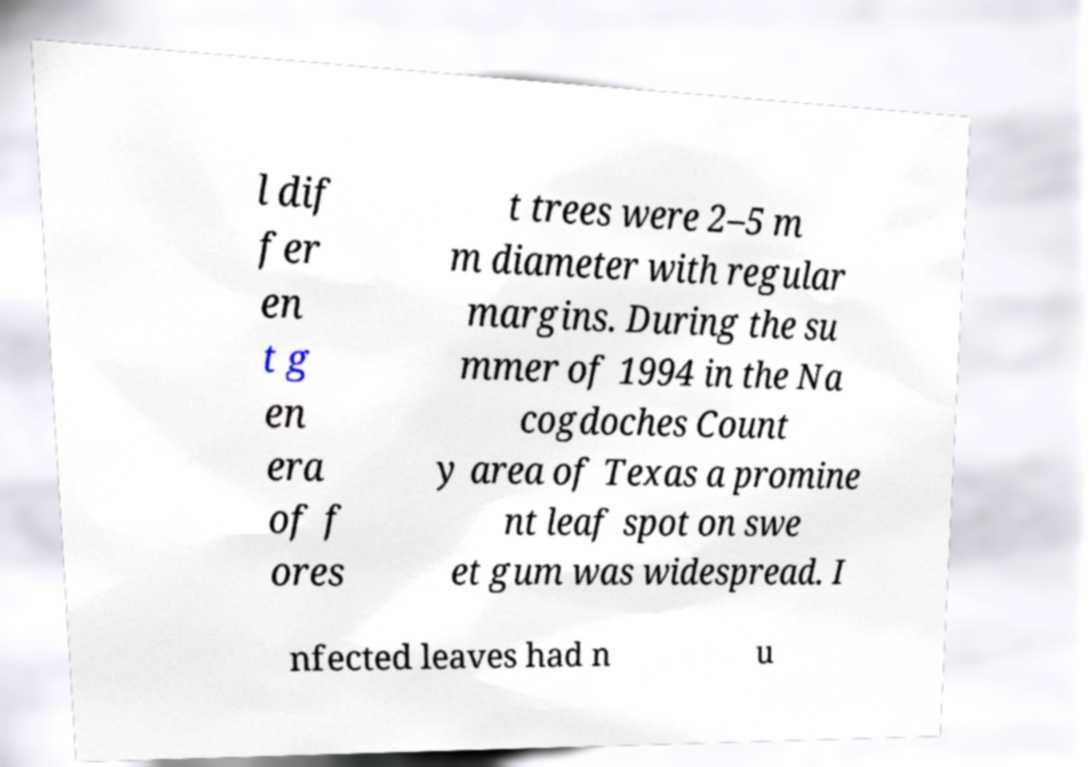Could you assist in decoding the text presented in this image and type it out clearly? l dif fer en t g en era of f ores t trees were 2–5 m m diameter with regular margins. During the su mmer of 1994 in the Na cogdoches Count y area of Texas a promine nt leaf spot on swe et gum was widespread. I nfected leaves had n u 